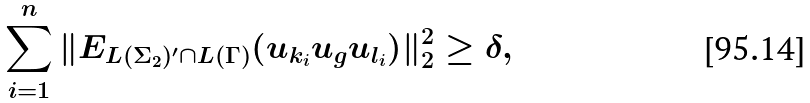<formula> <loc_0><loc_0><loc_500><loc_500>\sum _ { i = 1 } ^ { n } \| E _ { L ( \Sigma _ { 2 } ) ^ { \prime } \cap L ( \Gamma ) } ( u _ { k _ { i } } u _ { g } u _ { l _ { i } } ) \| _ { 2 } ^ { 2 } \geq \delta , \,</formula> 